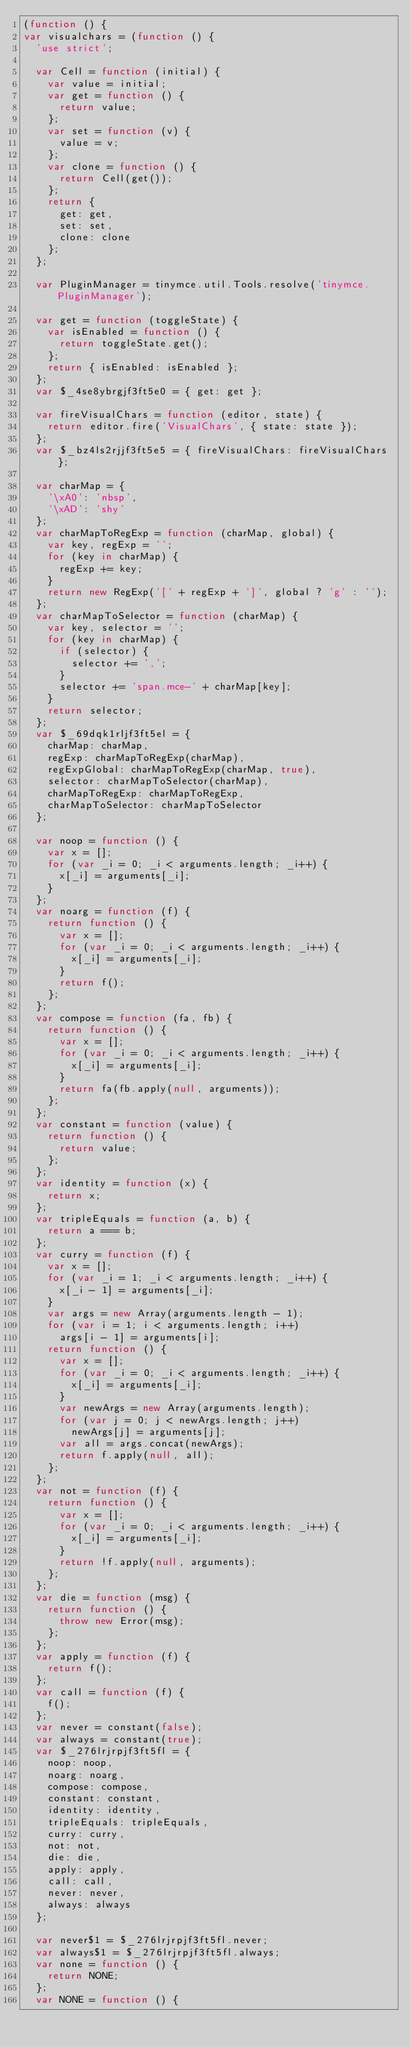<code> <loc_0><loc_0><loc_500><loc_500><_JavaScript_>(function () {
var visualchars = (function () {
  'use strict';

  var Cell = function (initial) {
    var value = initial;
    var get = function () {
      return value;
    };
    var set = function (v) {
      value = v;
    };
    var clone = function () {
      return Cell(get());
    };
    return {
      get: get,
      set: set,
      clone: clone
    };
  };

  var PluginManager = tinymce.util.Tools.resolve('tinymce.PluginManager');

  var get = function (toggleState) {
    var isEnabled = function () {
      return toggleState.get();
    };
    return { isEnabled: isEnabled };
  };
  var $_4se8ybrgjf3ft5e0 = { get: get };

  var fireVisualChars = function (editor, state) {
    return editor.fire('VisualChars', { state: state });
  };
  var $_bz4ls2rjjf3ft5e5 = { fireVisualChars: fireVisualChars };

  var charMap = {
    '\xA0': 'nbsp',
    '\xAD': 'shy'
  };
  var charMapToRegExp = function (charMap, global) {
    var key, regExp = '';
    for (key in charMap) {
      regExp += key;
    }
    return new RegExp('[' + regExp + ']', global ? 'g' : '');
  };
  var charMapToSelector = function (charMap) {
    var key, selector = '';
    for (key in charMap) {
      if (selector) {
        selector += ',';
      }
      selector += 'span.mce-' + charMap[key];
    }
    return selector;
  };
  var $_69dqk1rljf3ft5el = {
    charMap: charMap,
    regExp: charMapToRegExp(charMap),
    regExpGlobal: charMapToRegExp(charMap, true),
    selector: charMapToSelector(charMap),
    charMapToRegExp: charMapToRegExp,
    charMapToSelector: charMapToSelector
  };

  var noop = function () {
    var x = [];
    for (var _i = 0; _i < arguments.length; _i++) {
      x[_i] = arguments[_i];
    }
  };
  var noarg = function (f) {
    return function () {
      var x = [];
      for (var _i = 0; _i < arguments.length; _i++) {
        x[_i] = arguments[_i];
      }
      return f();
    };
  };
  var compose = function (fa, fb) {
    return function () {
      var x = [];
      for (var _i = 0; _i < arguments.length; _i++) {
        x[_i] = arguments[_i];
      }
      return fa(fb.apply(null, arguments));
    };
  };
  var constant = function (value) {
    return function () {
      return value;
    };
  };
  var identity = function (x) {
    return x;
  };
  var tripleEquals = function (a, b) {
    return a === b;
  };
  var curry = function (f) {
    var x = [];
    for (var _i = 1; _i < arguments.length; _i++) {
      x[_i - 1] = arguments[_i];
    }
    var args = new Array(arguments.length - 1);
    for (var i = 1; i < arguments.length; i++)
      args[i - 1] = arguments[i];
    return function () {
      var x = [];
      for (var _i = 0; _i < arguments.length; _i++) {
        x[_i] = arguments[_i];
      }
      var newArgs = new Array(arguments.length);
      for (var j = 0; j < newArgs.length; j++)
        newArgs[j] = arguments[j];
      var all = args.concat(newArgs);
      return f.apply(null, all);
    };
  };
  var not = function (f) {
    return function () {
      var x = [];
      for (var _i = 0; _i < arguments.length; _i++) {
        x[_i] = arguments[_i];
      }
      return !f.apply(null, arguments);
    };
  };
  var die = function (msg) {
    return function () {
      throw new Error(msg);
    };
  };
  var apply = function (f) {
    return f();
  };
  var call = function (f) {
    f();
  };
  var never = constant(false);
  var always = constant(true);
  var $_276lrjrpjf3ft5fl = {
    noop: noop,
    noarg: noarg,
    compose: compose,
    constant: constant,
    identity: identity,
    tripleEquals: tripleEquals,
    curry: curry,
    not: not,
    die: die,
    apply: apply,
    call: call,
    never: never,
    always: always
  };

  var never$1 = $_276lrjrpjf3ft5fl.never;
  var always$1 = $_276lrjrpjf3ft5fl.always;
  var none = function () {
    return NONE;
  };
  var NONE = function () {</code> 